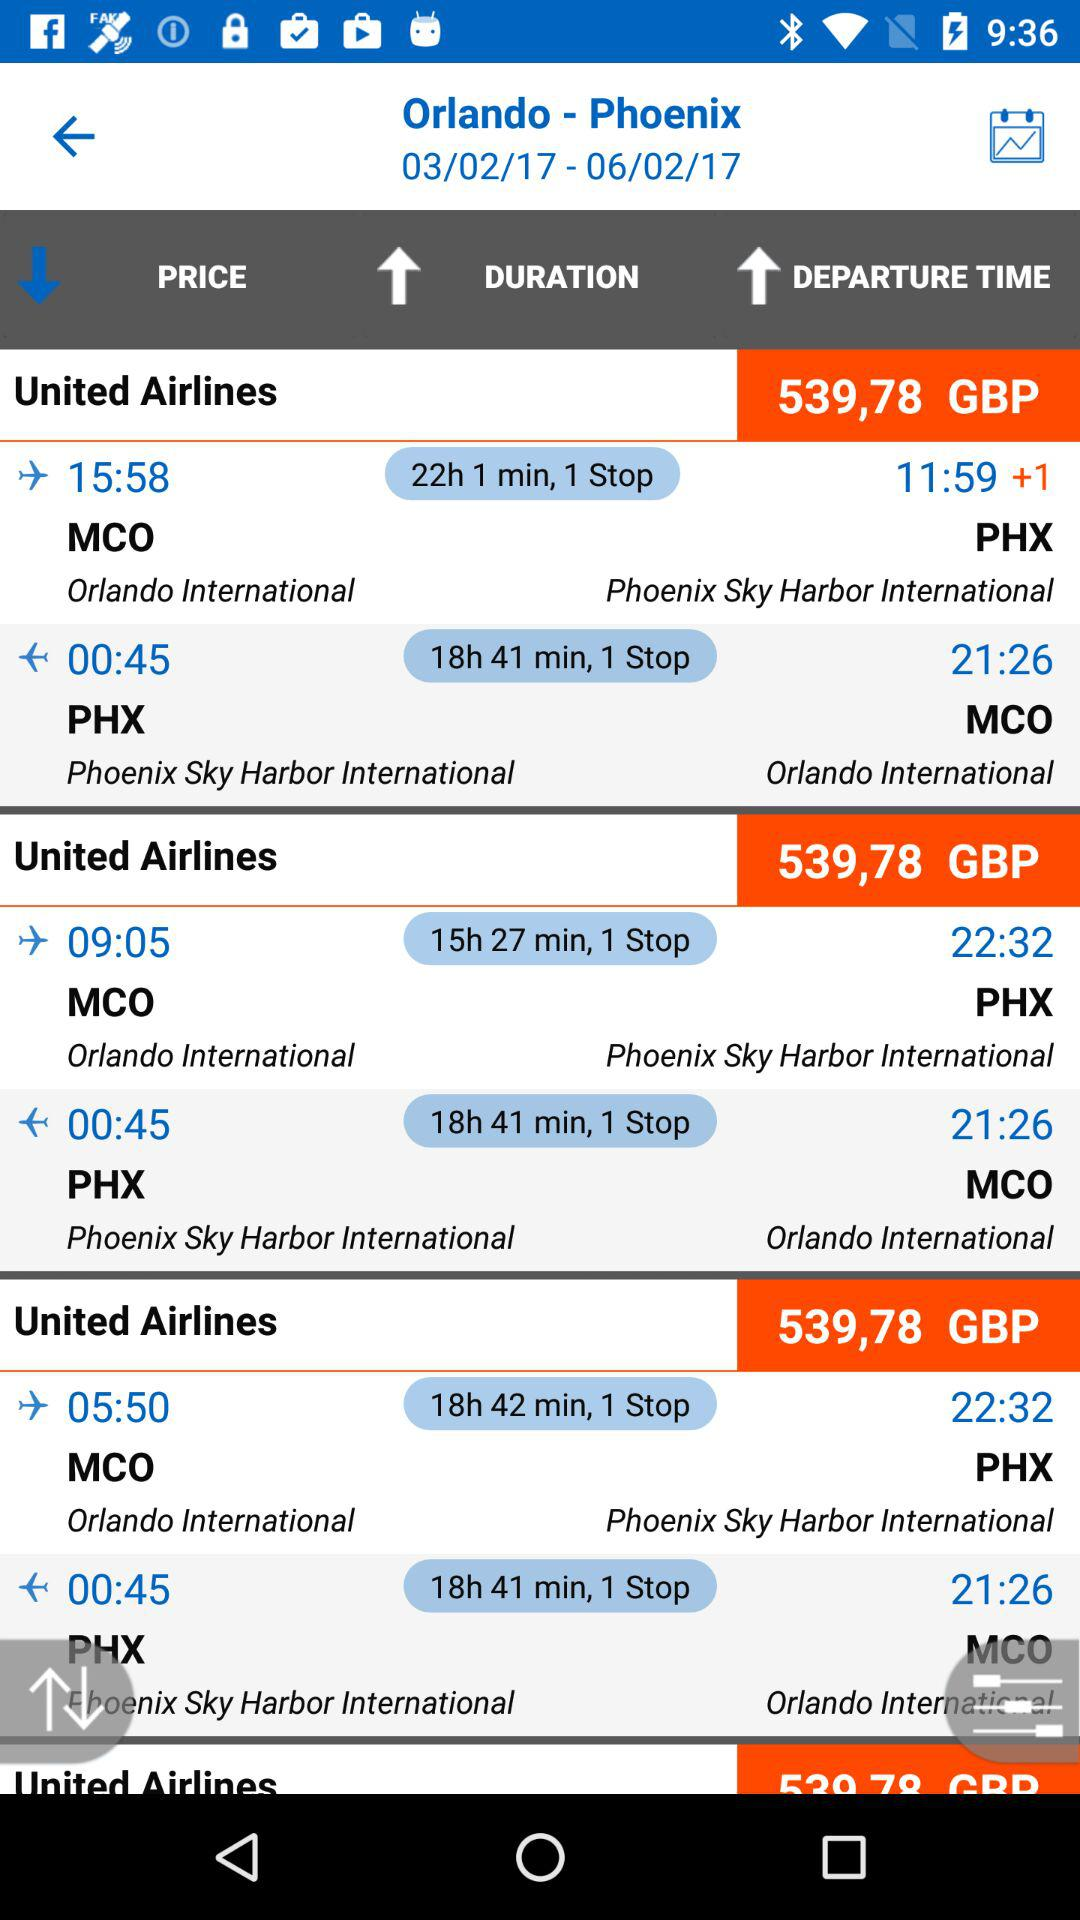What is the departure time from MCO for PHX of the first flight shown on the screen? The departure time from MCO for PHX of the first flight shown on the screen is 15:58. 